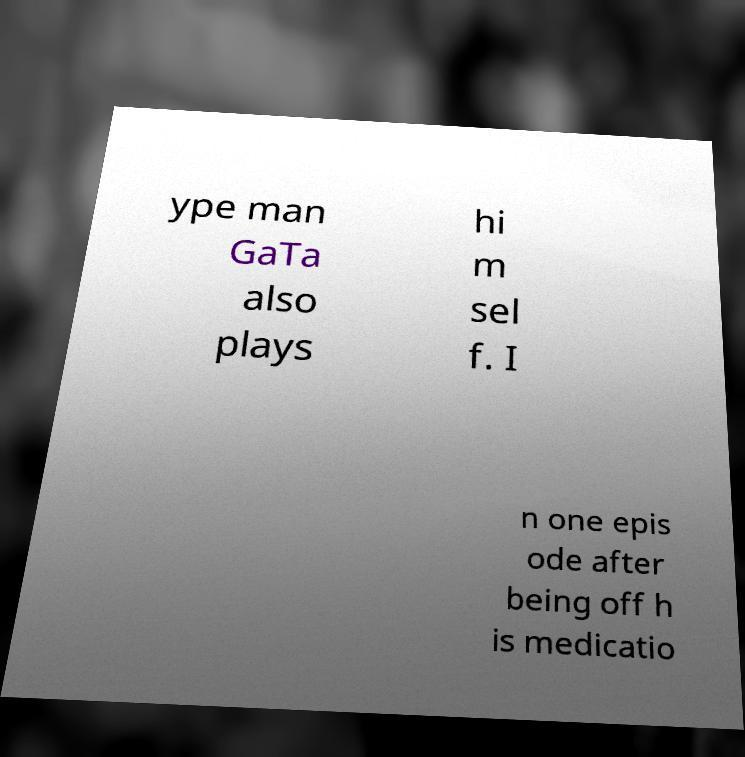Can you accurately transcribe the text from the provided image for me? ype man GaTa also plays hi m sel f. I n one epis ode after being off h is medicatio 